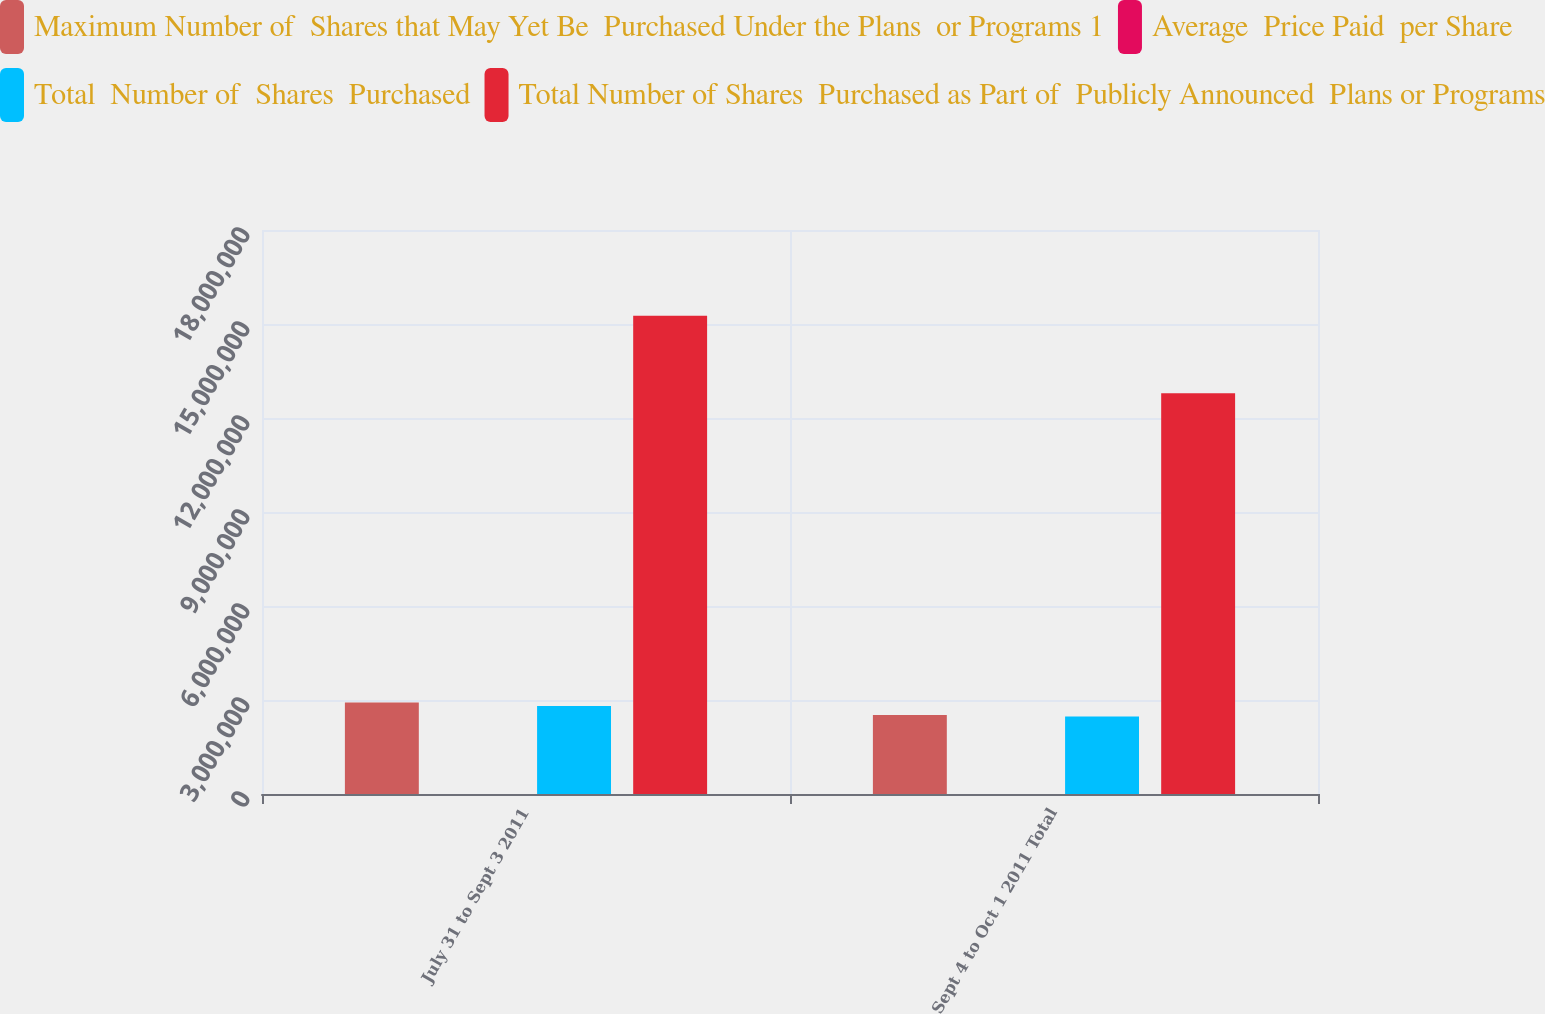<chart> <loc_0><loc_0><loc_500><loc_500><stacked_bar_chart><ecel><fcel>July 31 to Sept 3 2011<fcel>Sept 4 to Oct 1 2011 Total<nl><fcel>Maximum Number of  Shares that May Yet Be  Purchased Under the Plans  or Programs 1<fcel>2.91961e+06<fcel>2.52415e+06<nl><fcel>Average  Price Paid  per Share<fcel>16.97<fcel>17.16<nl><fcel>Total  Number of  Shares  Purchased<fcel>2.80748e+06<fcel>2.4698e+06<nl><fcel>Total Number of Shares  Purchased as Part of  Publicly Announced  Plans or Programs<fcel>1.52636e+07<fcel>1.27938e+07<nl></chart> 